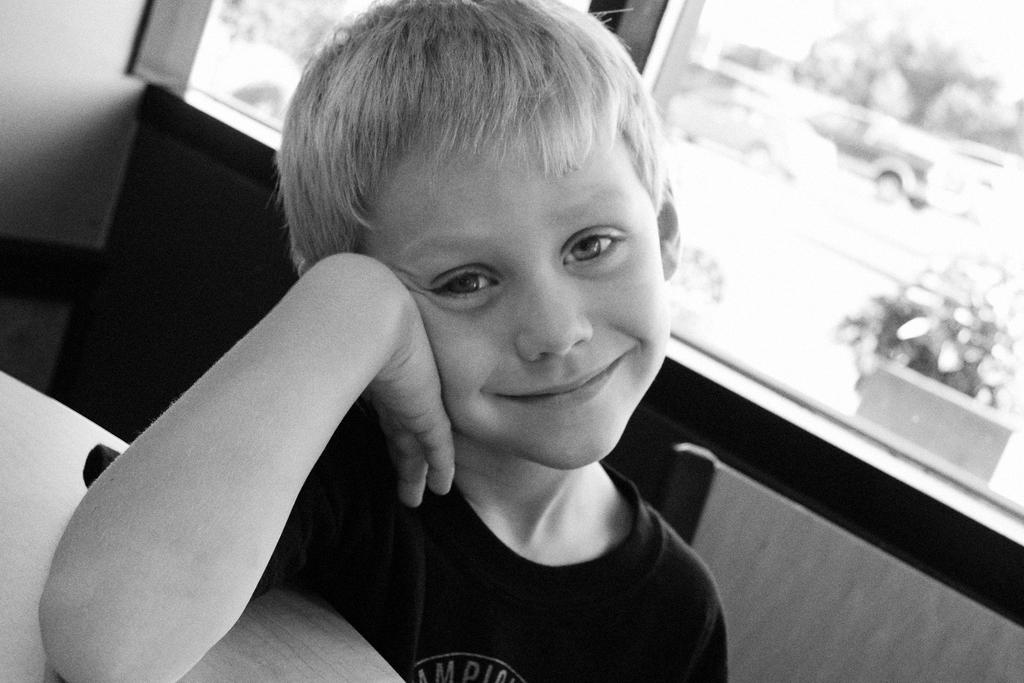Who is present in the image? There is a boy in the image. What piece of furniture can be seen in the image? There is a table and a chair in the image. What type of vehicles are visible in the image? There are cars in the image. How many rabbits are hopping on the table in the image? There are no rabbits present in the image; it features a boy, a table, a chair, and cars. 